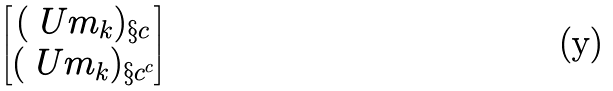Convert formula to latex. <formula><loc_0><loc_0><loc_500><loc_500>\begin{bmatrix} ( \ U m _ { k } ) _ { \S c } \\ ( \ U m _ { k } ) _ { \S c ^ { c } } \end{bmatrix}</formula> 